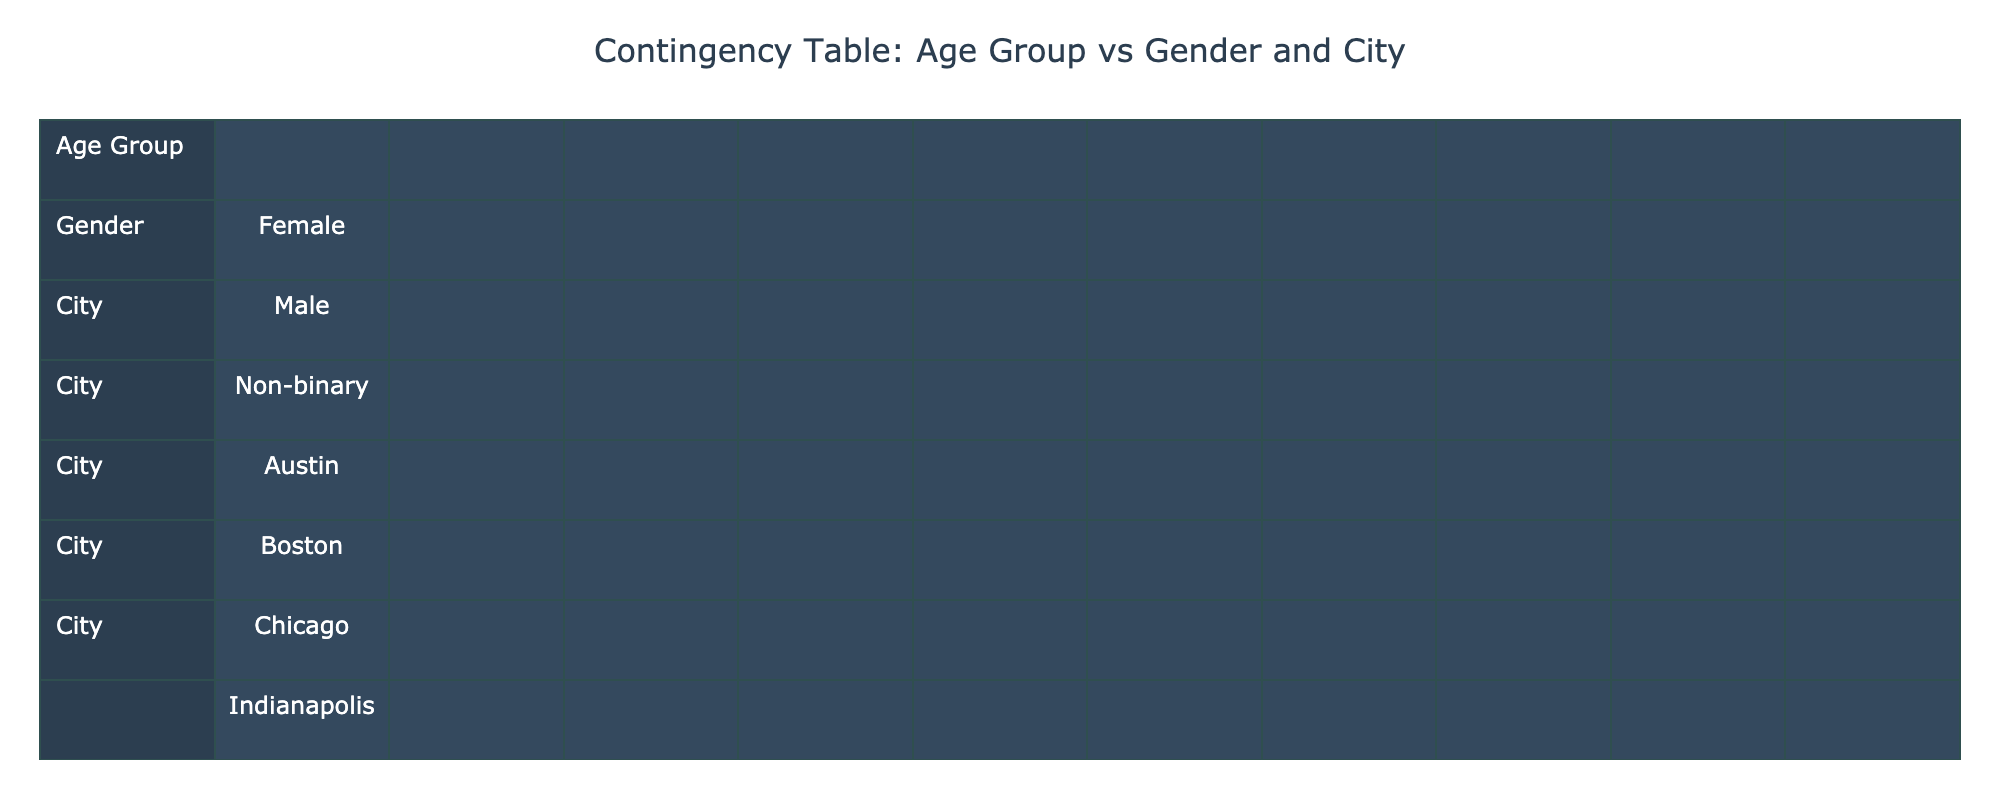What is the total attendance for the "Poetry in the Park" event? The attendance for the "Poetry in the Park" event is indicated in the table as 300. Thus, the total attendance for this specific event is simply 300.
Answer: 300 Which age group has the highest attendance for spoken word events in Chicago? In Chicago, the attendance data shows that the age group 25-34, which includes females at the Green Mill venue, has 160 attendees, while the 35-44 age group includes non-binary at the Poetry Foundation with only 80 attendees. Therefore, 25-34 has the highest attendance.
Answer: 25-34 Are there more females or males attending spoken word events in Los Angeles? The table indicates that there is one event in Los Angeles, which is "The Moth," showing an attendance of 120 for females. Since there are no events listed for males in Los Angeles, the conclusion is that females have a greater attendance.
Answer: More females What is the total attendance of spoken word events in New York? The events in New York include "The Bowery Poetry Club" (150), "The Nuyorican Poets Cafe" (200), "Word Up Community Bookshop" (90), and "The Poetry Project" (180). Adding these, the total attendance is calculated as 150 + 200 + 90 + 180 = 620.
Answer: 620 Is there an event with non-binary attendees in Boston? The table lists only one event in Boston, "Open Mic Night," and it indicates that the attendees are males (140). Therefore, there are no non-binary attendees in Boston for spoken word events.
Answer: No What is the attendance difference between the 18-24 and 35-44 age groups in Seattle? In Seattle, the attendance for the 18-24 age group ("City Arts Space") is 100, while there are no entries for the 35-44 age group. Therefore, the difference is calculated as 100 - 0 = 100.
Answer: 100 Which gender group has the highest attendance across all venues? By analyzing the total attendance for each gender: female has  property totals of 200 (Nuyorican Poets Cafe) + 160 (Green Mill) + 90 (Word Up) + 180 (Poetry Project) = 630; male attendees can be summed 150 (Bowery) + 120 (Moth) + 100 (City Arts) + 110 (Spoken Word Cafe) + 140 (Open Mic Night) = 620; Here, females lead with a higher number of attendees than males.
Answer: Female How many venues did not have any non-binary attendees? By examining the table, we notice that only the "Poetry Foundation" (80) has non-binary attendees. The other venues are either with males or females, confirming that 11 out of 12 listed showed no non-binary attendees. Thus, the number of venues without non-binary attendees is 11.
Answer: 11 